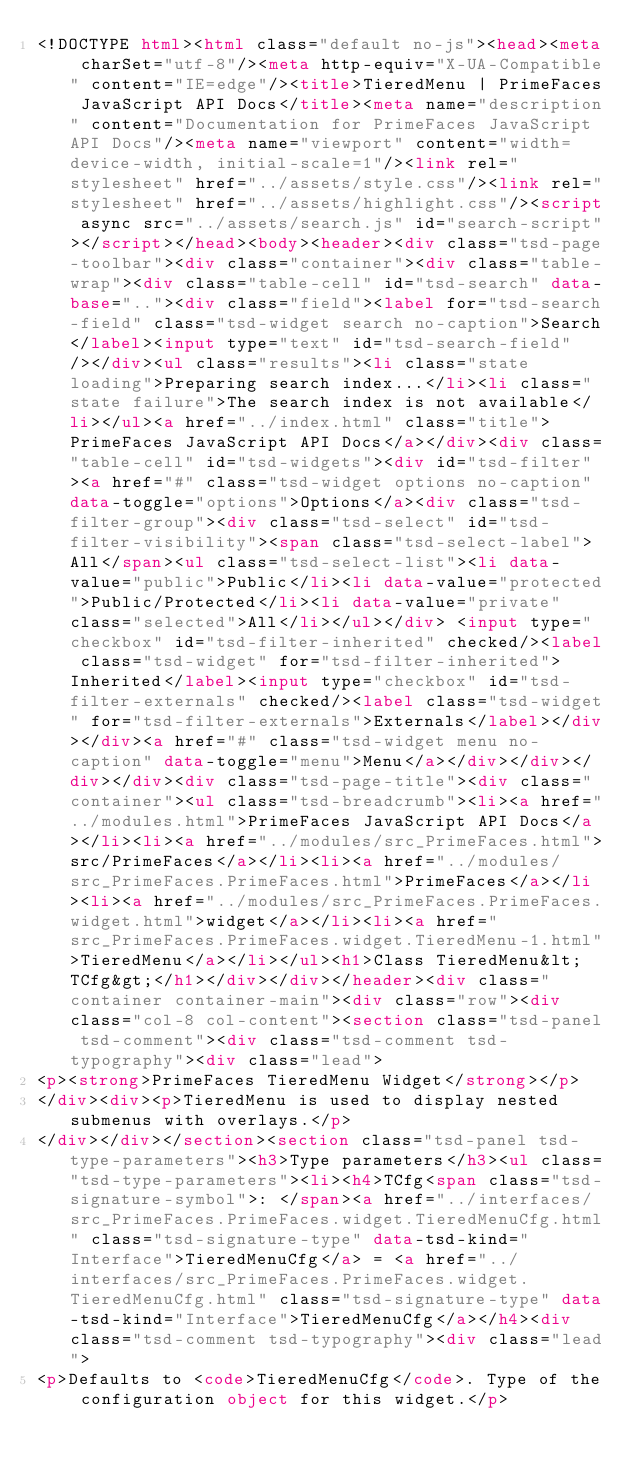Convert code to text. <code><loc_0><loc_0><loc_500><loc_500><_HTML_><!DOCTYPE html><html class="default no-js"><head><meta charSet="utf-8"/><meta http-equiv="X-UA-Compatible" content="IE=edge"/><title>TieredMenu | PrimeFaces JavaScript API Docs</title><meta name="description" content="Documentation for PrimeFaces JavaScript API Docs"/><meta name="viewport" content="width=device-width, initial-scale=1"/><link rel="stylesheet" href="../assets/style.css"/><link rel="stylesheet" href="../assets/highlight.css"/><script async src="../assets/search.js" id="search-script"></script></head><body><header><div class="tsd-page-toolbar"><div class="container"><div class="table-wrap"><div class="table-cell" id="tsd-search" data-base=".."><div class="field"><label for="tsd-search-field" class="tsd-widget search no-caption">Search</label><input type="text" id="tsd-search-field"/></div><ul class="results"><li class="state loading">Preparing search index...</li><li class="state failure">The search index is not available</li></ul><a href="../index.html" class="title">PrimeFaces JavaScript API Docs</a></div><div class="table-cell" id="tsd-widgets"><div id="tsd-filter"><a href="#" class="tsd-widget options no-caption" data-toggle="options">Options</a><div class="tsd-filter-group"><div class="tsd-select" id="tsd-filter-visibility"><span class="tsd-select-label">All</span><ul class="tsd-select-list"><li data-value="public">Public</li><li data-value="protected">Public/Protected</li><li data-value="private" class="selected">All</li></ul></div> <input type="checkbox" id="tsd-filter-inherited" checked/><label class="tsd-widget" for="tsd-filter-inherited">Inherited</label><input type="checkbox" id="tsd-filter-externals" checked/><label class="tsd-widget" for="tsd-filter-externals">Externals</label></div></div><a href="#" class="tsd-widget menu no-caption" data-toggle="menu">Menu</a></div></div></div></div><div class="tsd-page-title"><div class="container"><ul class="tsd-breadcrumb"><li><a href="../modules.html">PrimeFaces JavaScript API Docs</a></li><li><a href="../modules/src_PrimeFaces.html">src/PrimeFaces</a></li><li><a href="../modules/src_PrimeFaces.PrimeFaces.html">PrimeFaces</a></li><li><a href="../modules/src_PrimeFaces.PrimeFaces.widget.html">widget</a></li><li><a href="src_PrimeFaces.PrimeFaces.widget.TieredMenu-1.html">TieredMenu</a></li></ul><h1>Class TieredMenu&lt;TCfg&gt;</h1></div></div></header><div class="container container-main"><div class="row"><div class="col-8 col-content"><section class="tsd-panel tsd-comment"><div class="tsd-comment tsd-typography"><div class="lead">
<p><strong>PrimeFaces TieredMenu Widget</strong></p>
</div><div><p>TieredMenu is used to display nested submenus with overlays.</p>
</div></div></section><section class="tsd-panel tsd-type-parameters"><h3>Type parameters</h3><ul class="tsd-type-parameters"><li><h4>TCfg<span class="tsd-signature-symbol">: </span><a href="../interfaces/src_PrimeFaces.PrimeFaces.widget.TieredMenuCfg.html" class="tsd-signature-type" data-tsd-kind="Interface">TieredMenuCfg</a> = <a href="../interfaces/src_PrimeFaces.PrimeFaces.widget.TieredMenuCfg.html" class="tsd-signature-type" data-tsd-kind="Interface">TieredMenuCfg</a></h4><div class="tsd-comment tsd-typography"><div class="lead">
<p>Defaults to <code>TieredMenuCfg</code>. Type of the configuration object for this widget.</p></code> 